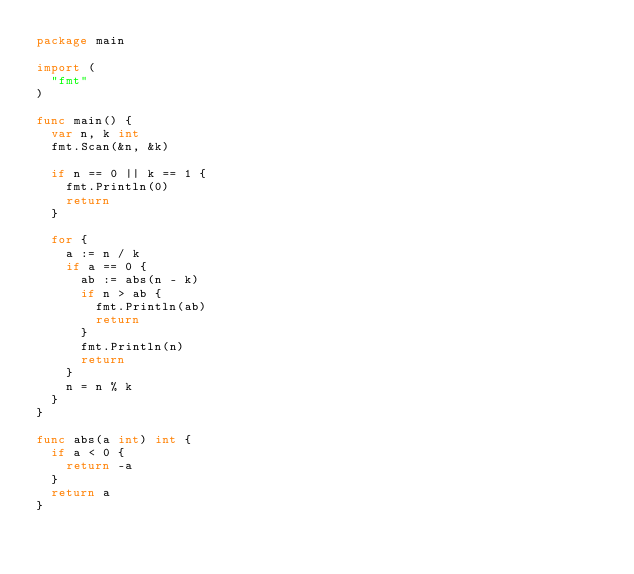<code> <loc_0><loc_0><loc_500><loc_500><_Go_>package main

import (
	"fmt"
)

func main() {
	var n, k int
	fmt.Scan(&n, &k)

	if n == 0 || k == 1 {
		fmt.Println(0)
		return
	}

	for {
		a := n / k
		if a == 0 {
			ab := abs(n - k)
			if n > ab {
				fmt.Println(ab)
				return
			}
			fmt.Println(n)
			return
		}
		n = n % k
	}
}

func abs(a int) int {
	if a < 0 {
		return -a
	}
	return a
}</code> 